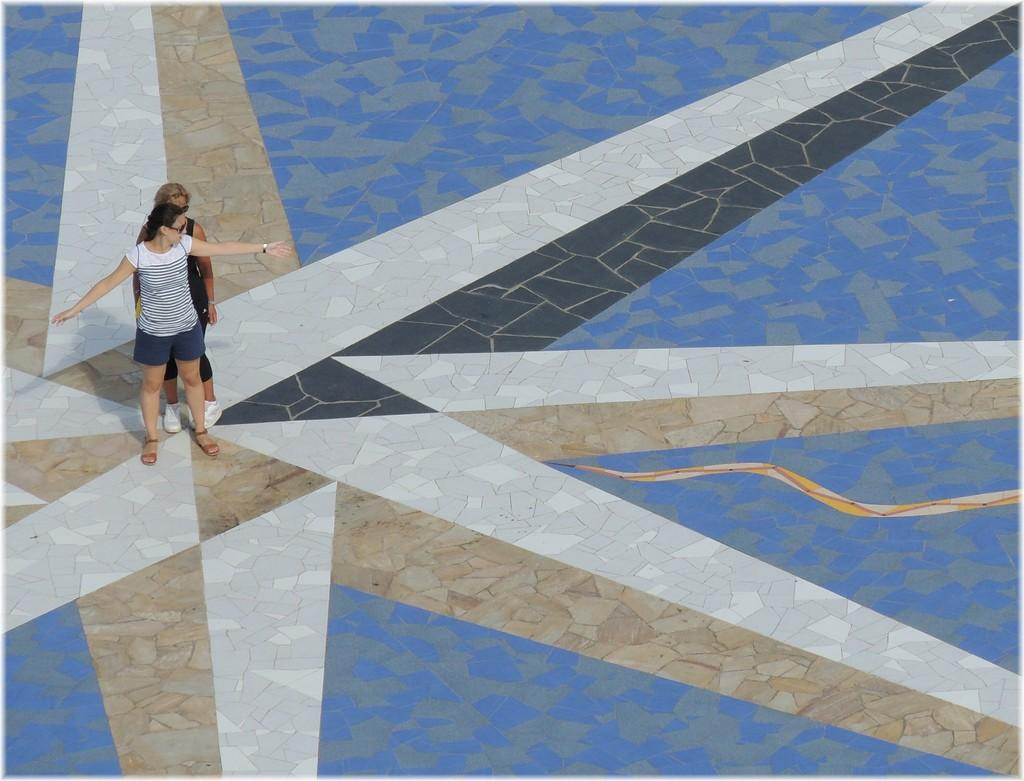How many people are in the image? There are two persons standing on the left side of the image. What can be seen at the bottom of the image? There is a floor visible at the bottom of the image. What boundary is being touched by the persons in the image? There is no boundary present in the image, and the persons are not touching any boundaries. 